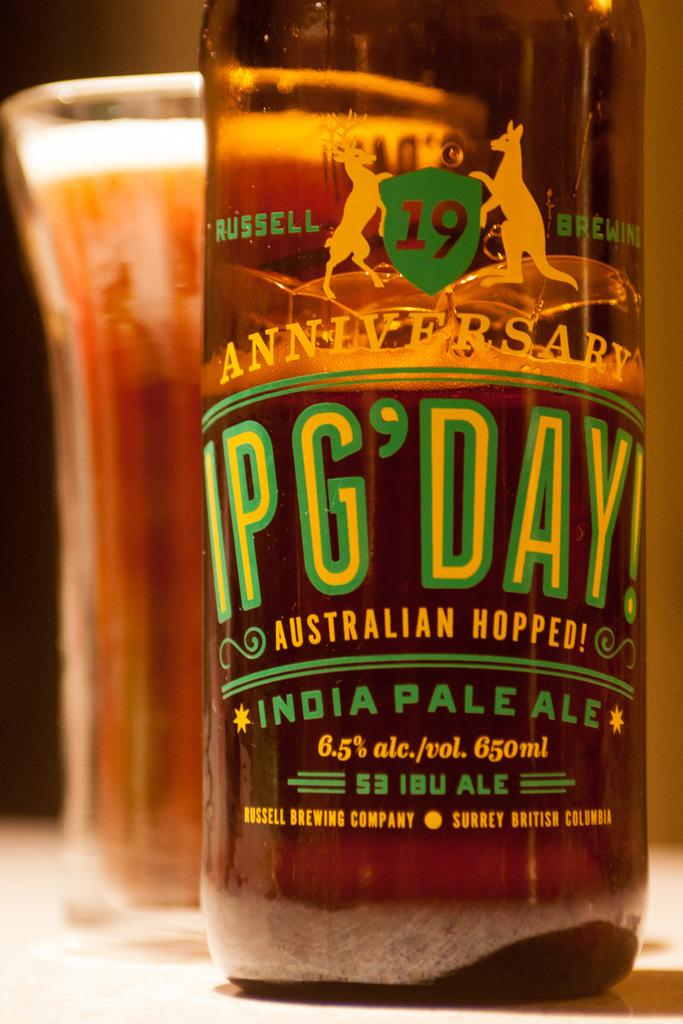<image>
Describe the image concisely. Bottle of India Pale Ale anniversary edition called IPG'Day 